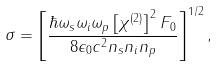Convert formula to latex. <formula><loc_0><loc_0><loc_500><loc_500>\sigma = \left [ \frac { \hbar { \omega } _ { s } \omega _ { i } \omega _ { p } \left [ \chi ^ { ( 2 ) } \right ] ^ { 2 } F _ { 0 } } { 8 \epsilon _ { 0 } c ^ { 2 } n _ { s } n _ { i } n _ { p } } \right ] ^ { 1 / 2 } ,</formula> 